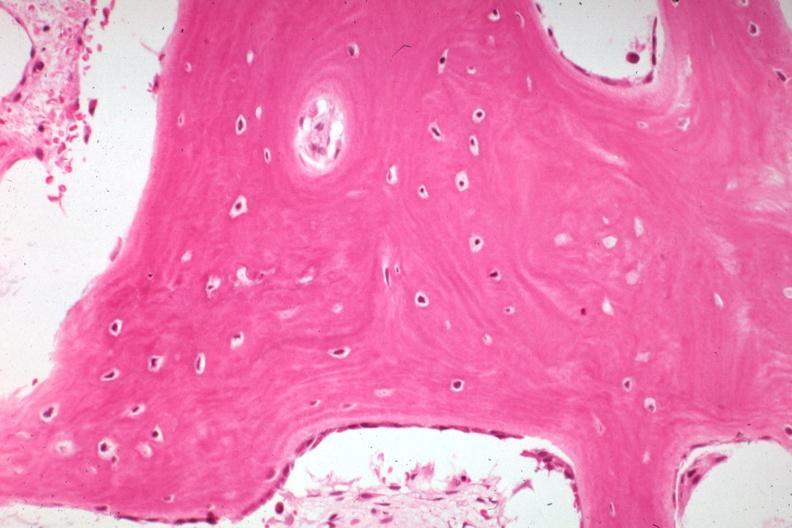what is present?
Answer the question using a single word or phrase. Joints 